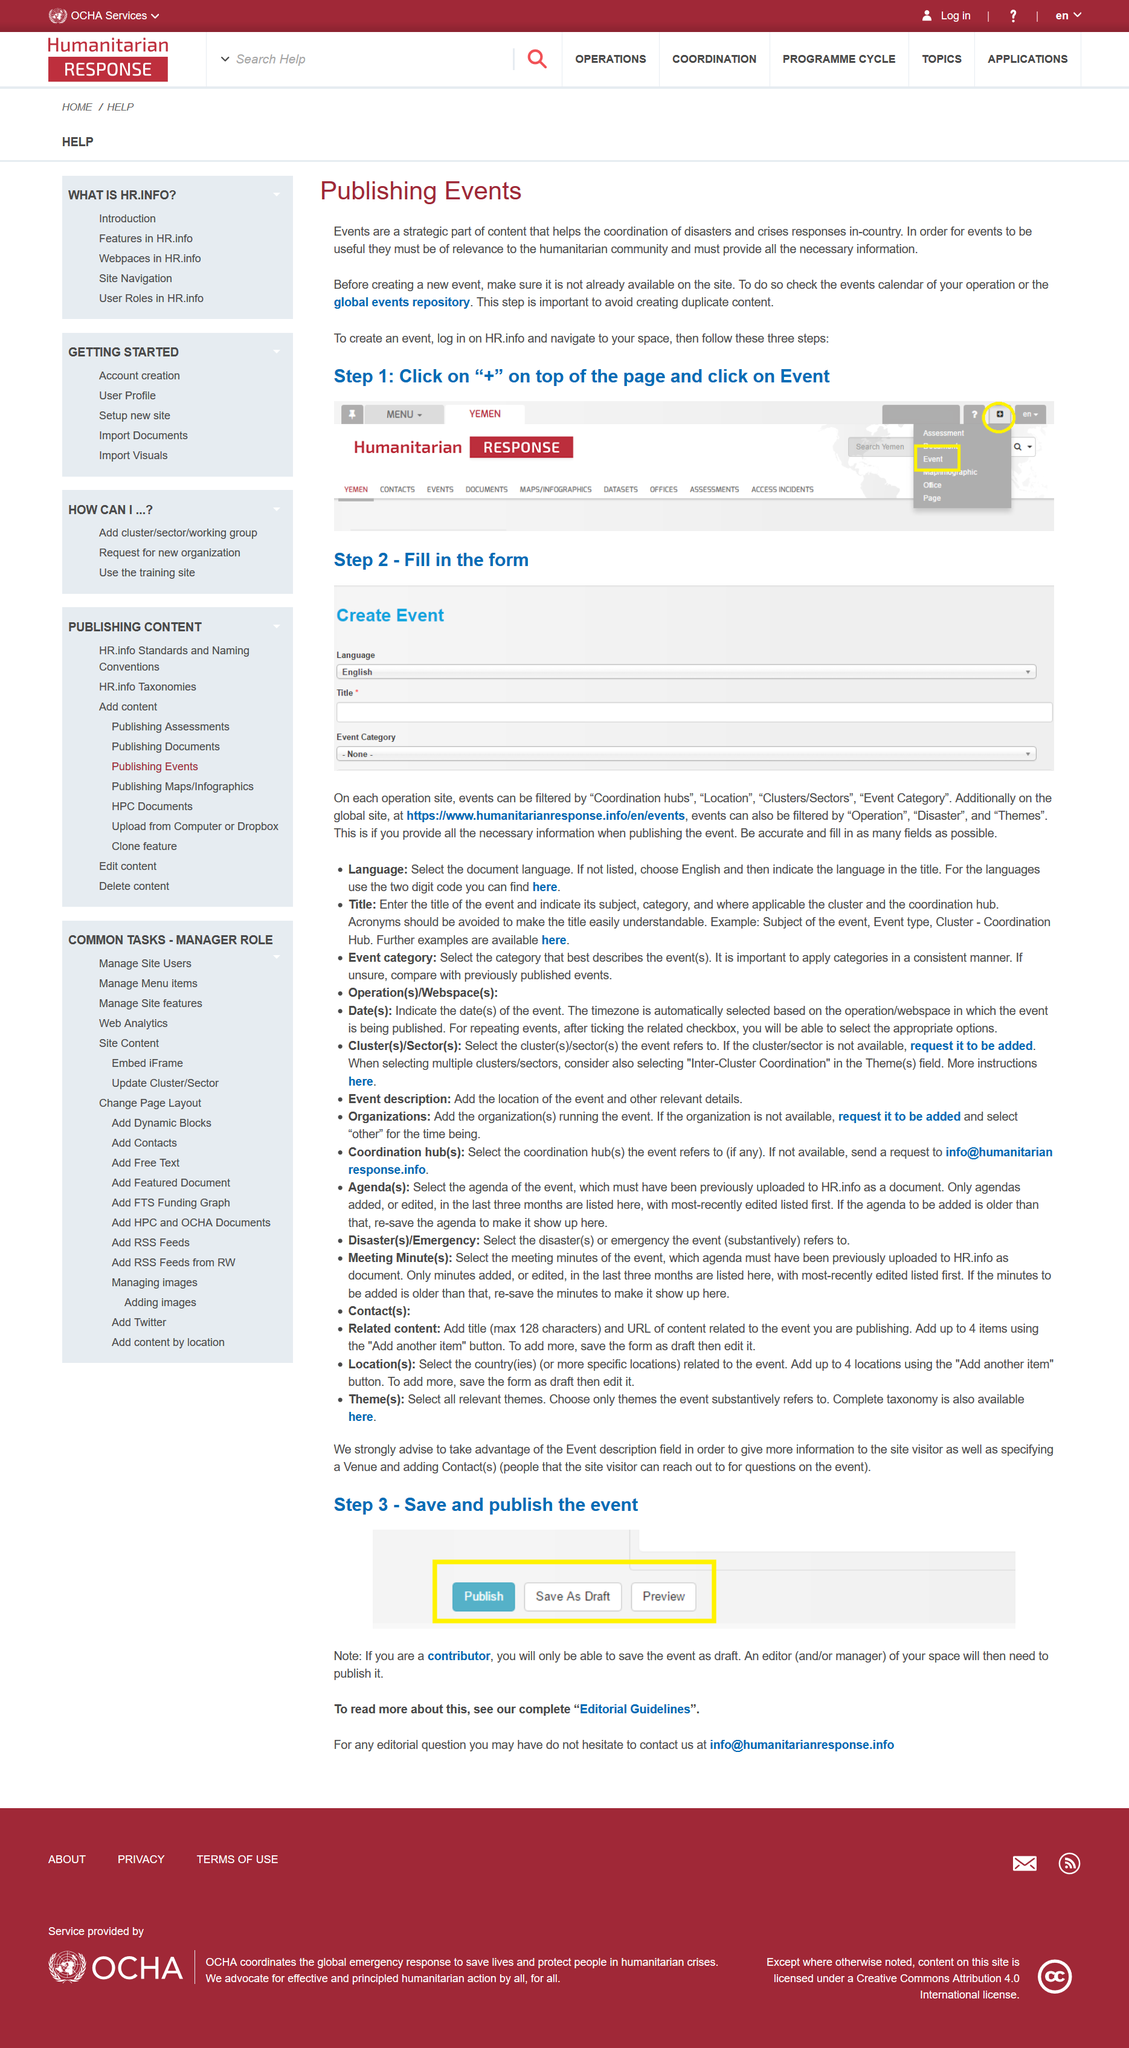Indicate a few pertinent items in this graphic. It is necessary to log in in order to create an event. Before creating meeting minutes, it is necessary to create an agenda document that outlines the items to be discussed during the meeting. The purpose of completing the form is to fill in the form in order to create an event. The title of the page used in the example image under Step 1 is 'humanitarian response', as indicated by the title at the top of the page in the image. It is recommended to review the events calendar for your operation or the global events repository before creating an event to ensure that your proposed event does not conflict with existing events or schedules. 